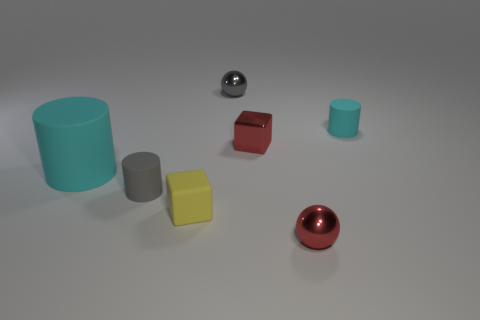What is the size of the red block?
Ensure brevity in your answer.  Small. What size is the cylinder that is behind the gray cylinder and in front of the small cyan matte thing?
Provide a short and direct response. Large. There is a red object that is behind the large matte cylinder; what is its shape?
Provide a succinct answer. Cube. Is the yellow thing made of the same material as the tiny ball in front of the gray shiny ball?
Keep it short and to the point. No. Does the tiny cyan object have the same shape as the big cyan matte thing?
Give a very brief answer. Yes. What is the material of the other thing that is the same shape as the yellow thing?
Keep it short and to the point. Metal. What color is the small matte thing that is both behind the small yellow rubber thing and in front of the small cyan object?
Ensure brevity in your answer.  Gray. What color is the tiny matte block?
Provide a succinct answer. Yellow. There is a sphere that is the same color as the tiny shiny block; what is it made of?
Make the answer very short. Metal. Are there any other matte things of the same shape as the tiny gray matte thing?
Keep it short and to the point. Yes. 